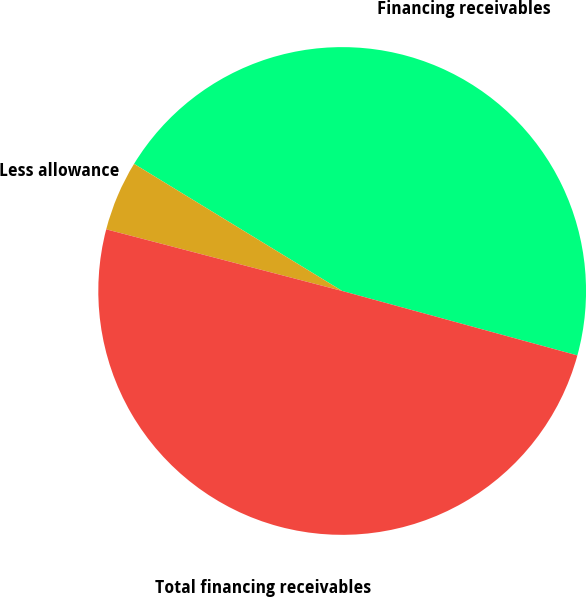Convert chart to OTSL. <chart><loc_0><loc_0><loc_500><loc_500><pie_chart><fcel>Financing receivables<fcel>Less allowance<fcel>Total financing receivables<nl><fcel>45.53%<fcel>4.66%<fcel>49.81%<nl></chart> 